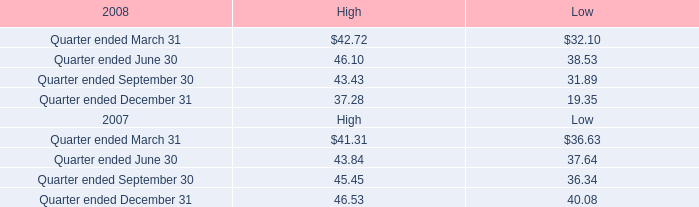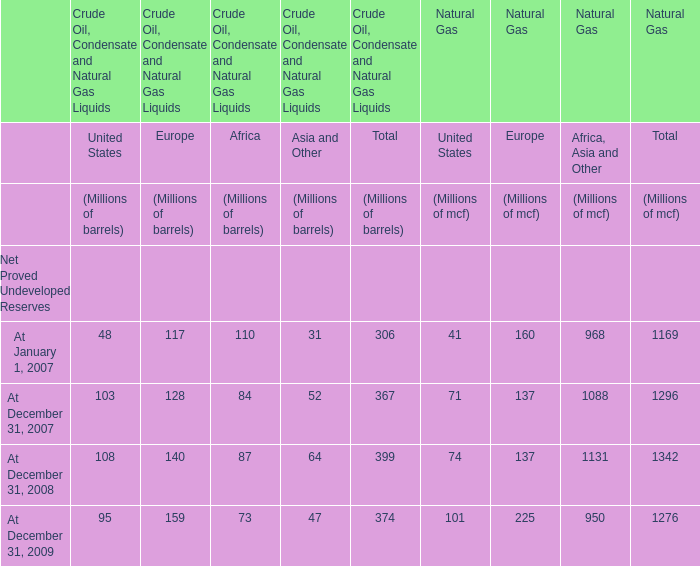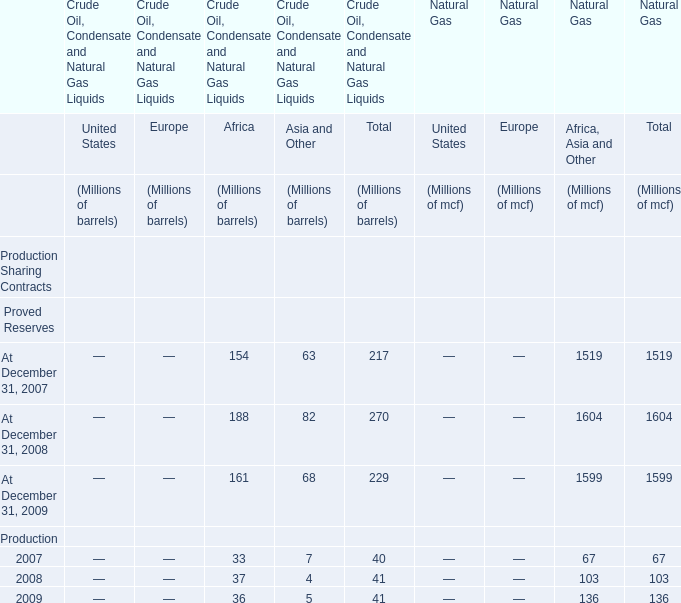In the section with the most Africa, what is the growth rate of Asia and Other? 
Computations: ((82 - 68) / 68)
Answer: 0.20588. 